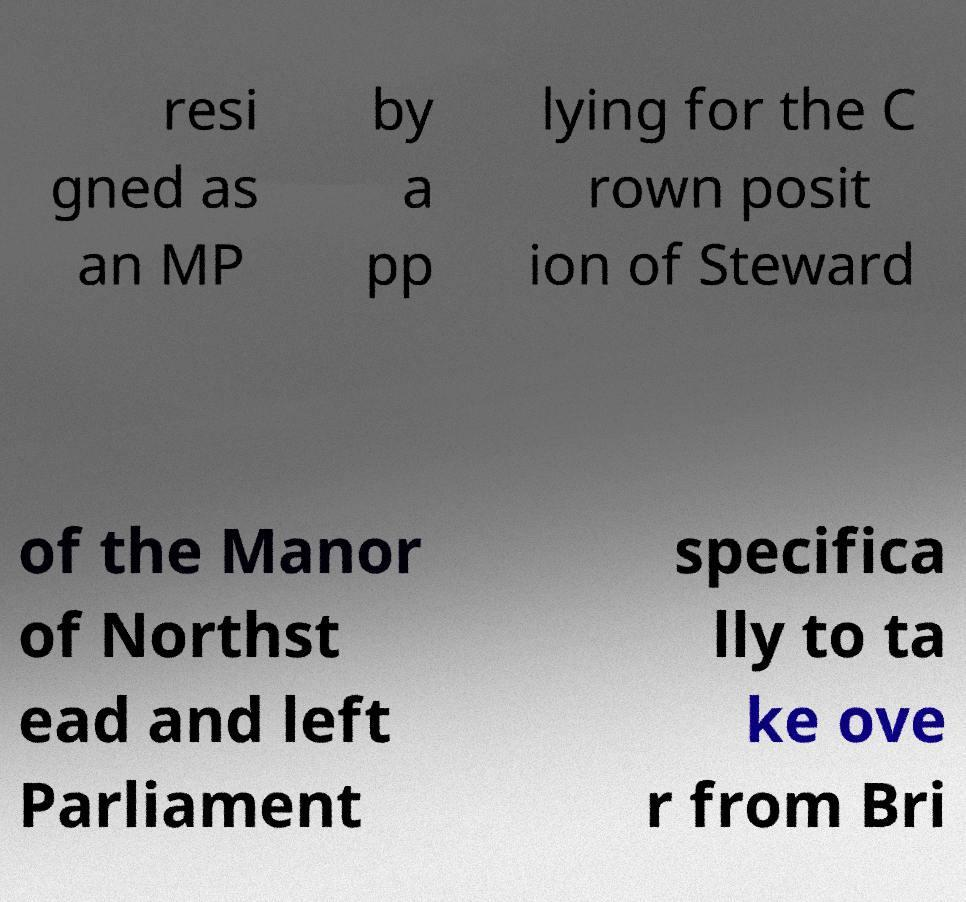Can you accurately transcribe the text from the provided image for me? resi gned as an MP by a pp lying for the C rown posit ion of Steward of the Manor of Northst ead and left Parliament specifica lly to ta ke ove r from Bri 